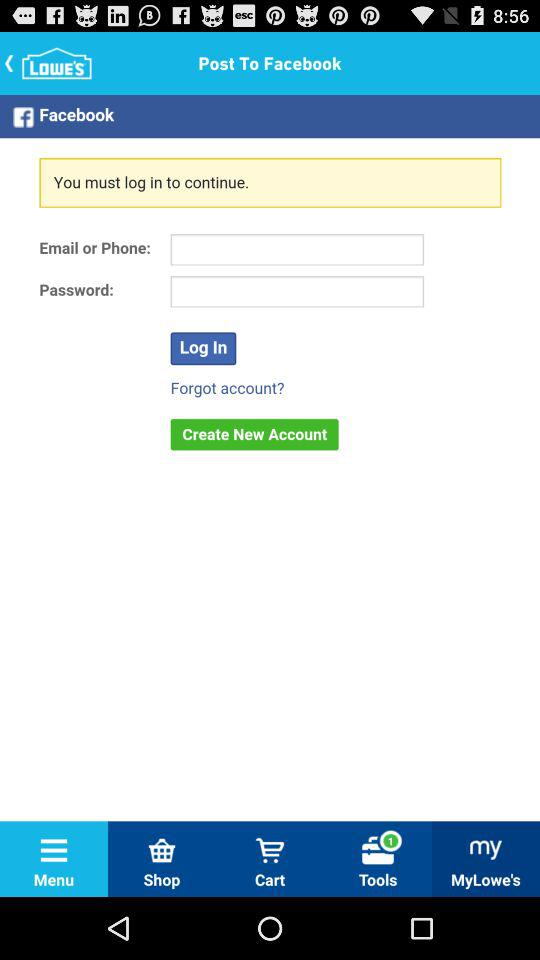How many input fields are there for logging in to Facebook?
Answer the question using a single word or phrase. 2 